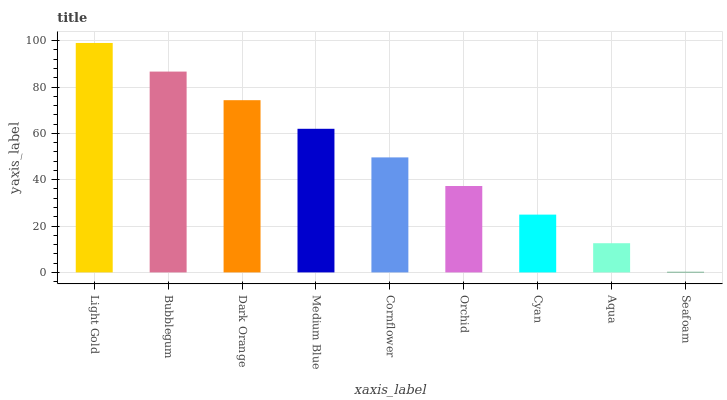Is Seafoam the minimum?
Answer yes or no. Yes. Is Light Gold the maximum?
Answer yes or no. Yes. Is Bubblegum the minimum?
Answer yes or no. No. Is Bubblegum the maximum?
Answer yes or no. No. Is Light Gold greater than Bubblegum?
Answer yes or no. Yes. Is Bubblegum less than Light Gold?
Answer yes or no. Yes. Is Bubblegum greater than Light Gold?
Answer yes or no. No. Is Light Gold less than Bubblegum?
Answer yes or no. No. Is Cornflower the high median?
Answer yes or no. Yes. Is Cornflower the low median?
Answer yes or no. Yes. Is Cyan the high median?
Answer yes or no. No. Is Cyan the low median?
Answer yes or no. No. 